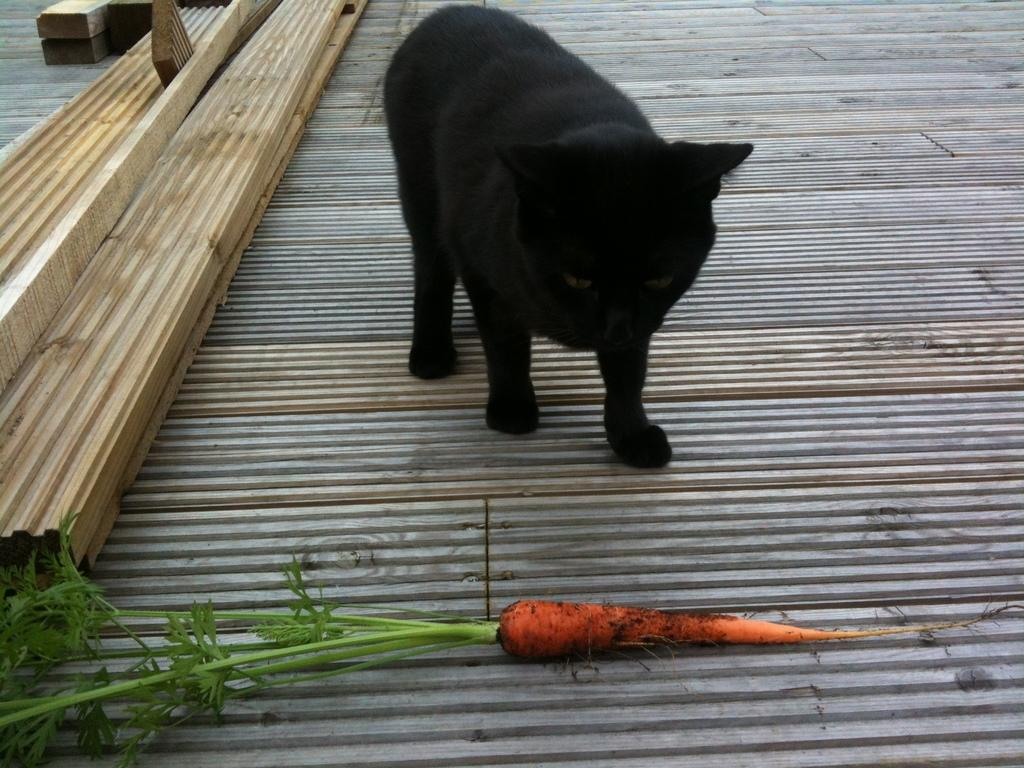What type of animal is in the image? There is a black color cat in the image. Where is the cat located? The cat is on the floor. What vegetable is present in the image? There is a carrot with leaves in the image. How is the carrot positioned in relation to the cat? The carrot is in front of the cat. What can be seen on the left side of the image? There are wooden planks on the left side of the image. What type of knowledge is the cat acquiring from the sleet in the image? There is no sleet present in the image, and therefore no knowledge acquisition can be observed. What is the rod used for in the image? There is no rod present in the image. 